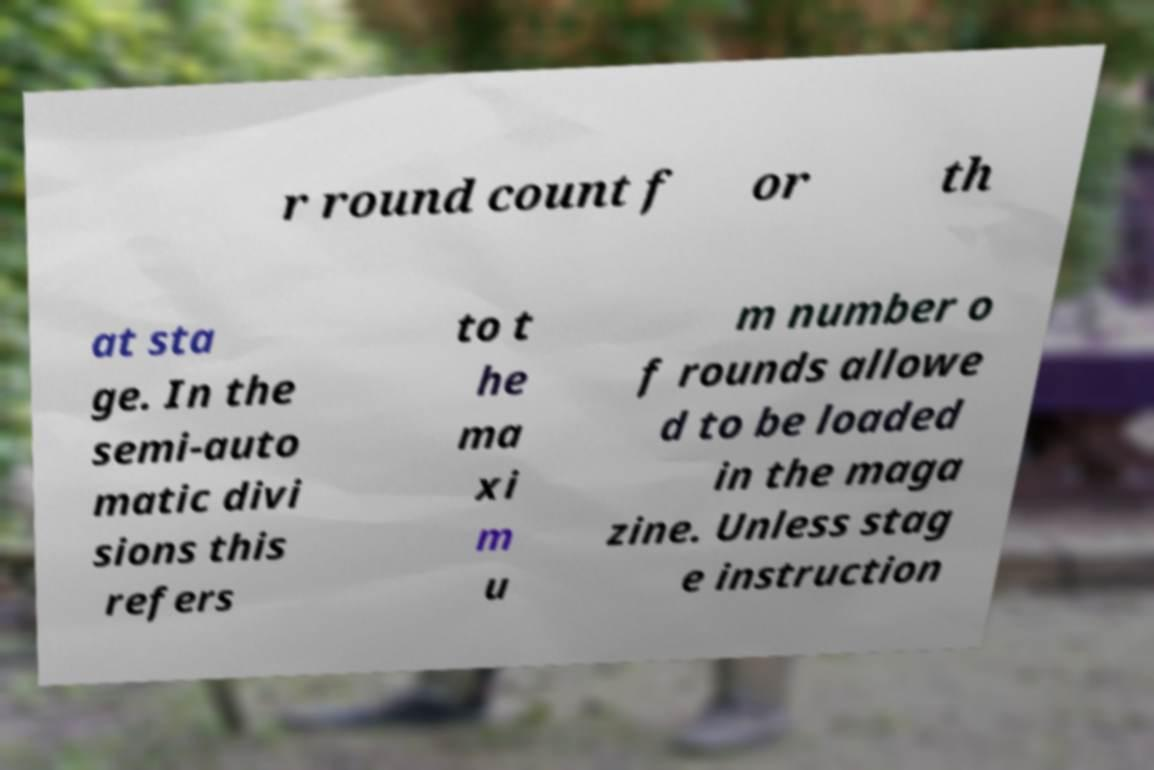Could you assist in decoding the text presented in this image and type it out clearly? r round count f or th at sta ge. In the semi-auto matic divi sions this refers to t he ma xi m u m number o f rounds allowe d to be loaded in the maga zine. Unless stag e instruction 